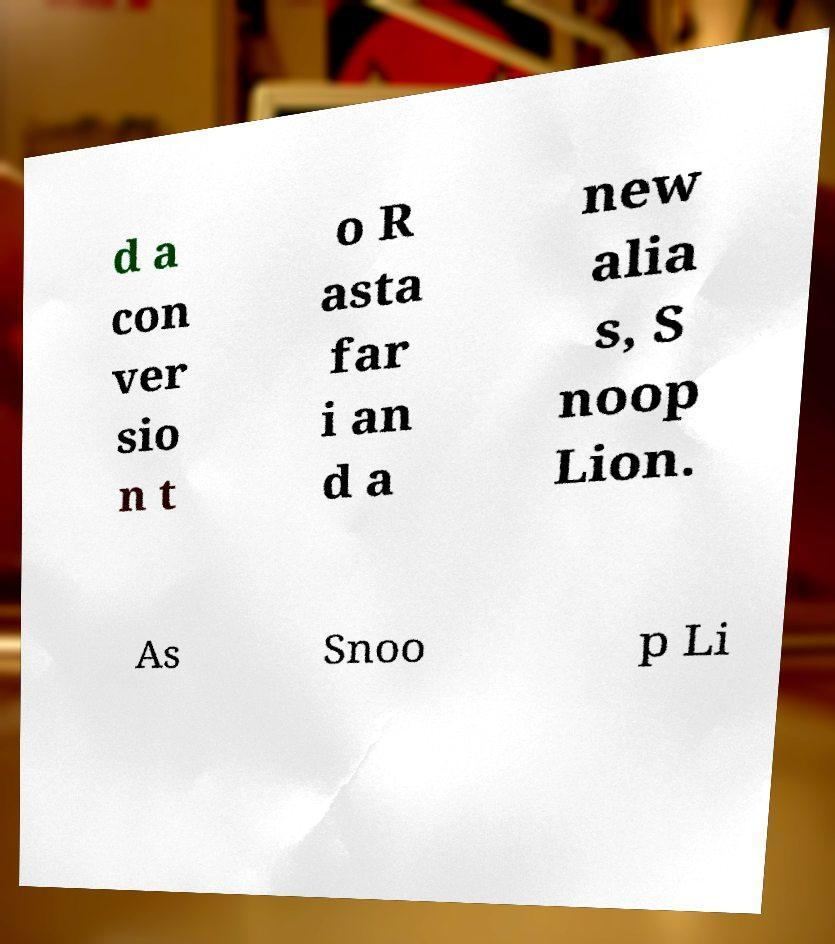Can you accurately transcribe the text from the provided image for me? d a con ver sio n t o R asta far i an d a new alia s, S noop Lion. As Snoo p Li 